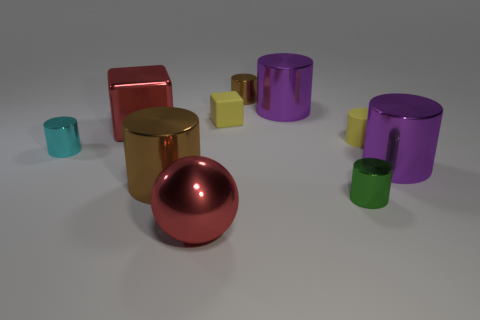How many brown cylinders must be subtracted to get 1 brown cylinders? 1 Subtract 0 blue balls. How many objects are left? 10 Subtract all balls. How many objects are left? 9 Subtract 4 cylinders. How many cylinders are left? 3 Subtract all brown spheres. Subtract all yellow cylinders. How many spheres are left? 1 Subtract all blue cubes. How many yellow balls are left? 0 Subtract all tiny blue balls. Subtract all small green shiny objects. How many objects are left? 9 Add 2 metal spheres. How many metal spheres are left? 3 Add 9 small cubes. How many small cubes exist? 10 Subtract all yellow blocks. How many blocks are left? 1 